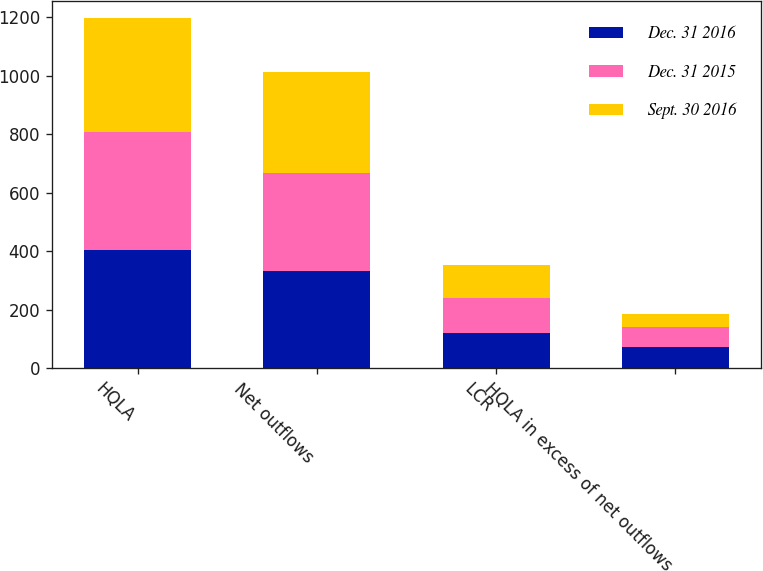Convert chart. <chart><loc_0><loc_0><loc_500><loc_500><stacked_bar_chart><ecel><fcel>HQLA<fcel>Net outflows<fcel>LCR<fcel>HQLA in excess of net outflows<nl><fcel>Dec. 31 2016<fcel>403.7<fcel>332.5<fcel>121<fcel>71.3<nl><fcel>Dec. 31 2015<fcel>403.8<fcel>335.3<fcel>120<fcel>68.5<nl><fcel>Sept. 30 2016<fcel>389.2<fcel>344.4<fcel>113<fcel>44.8<nl></chart> 